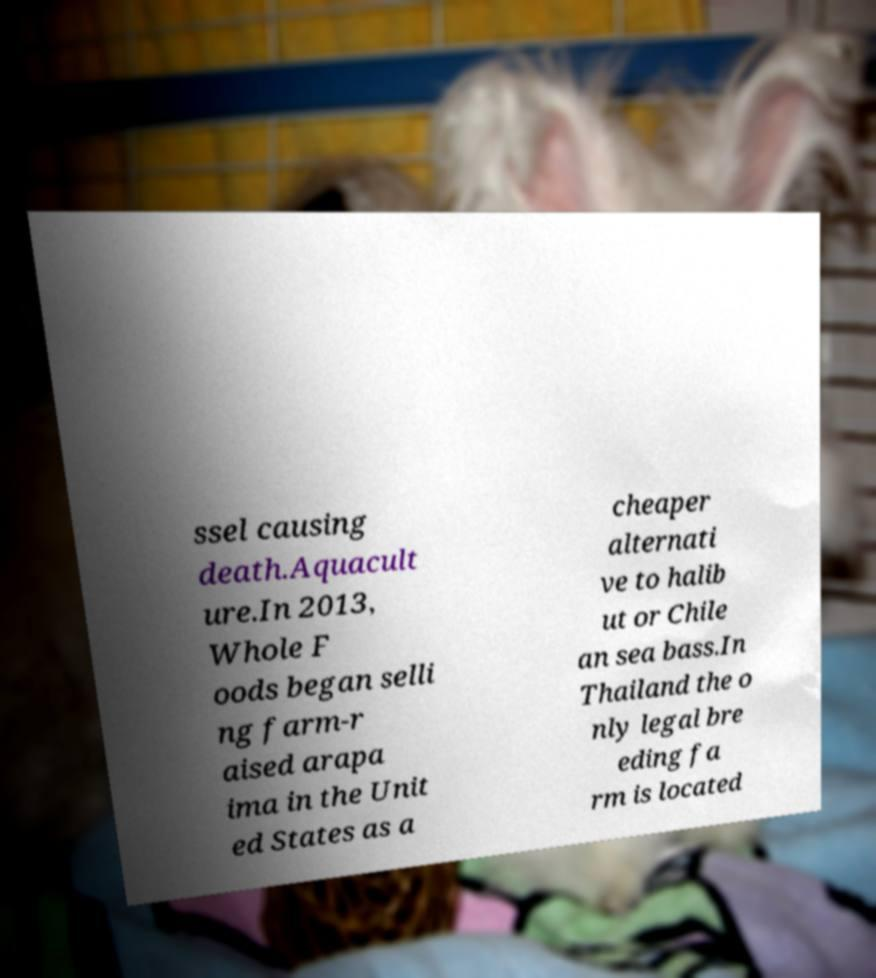Can you read and provide the text displayed in the image?This photo seems to have some interesting text. Can you extract and type it out for me? ssel causing death.Aquacult ure.In 2013, Whole F oods began selli ng farm-r aised arapa ima in the Unit ed States as a cheaper alternati ve to halib ut or Chile an sea bass.In Thailand the o nly legal bre eding fa rm is located 